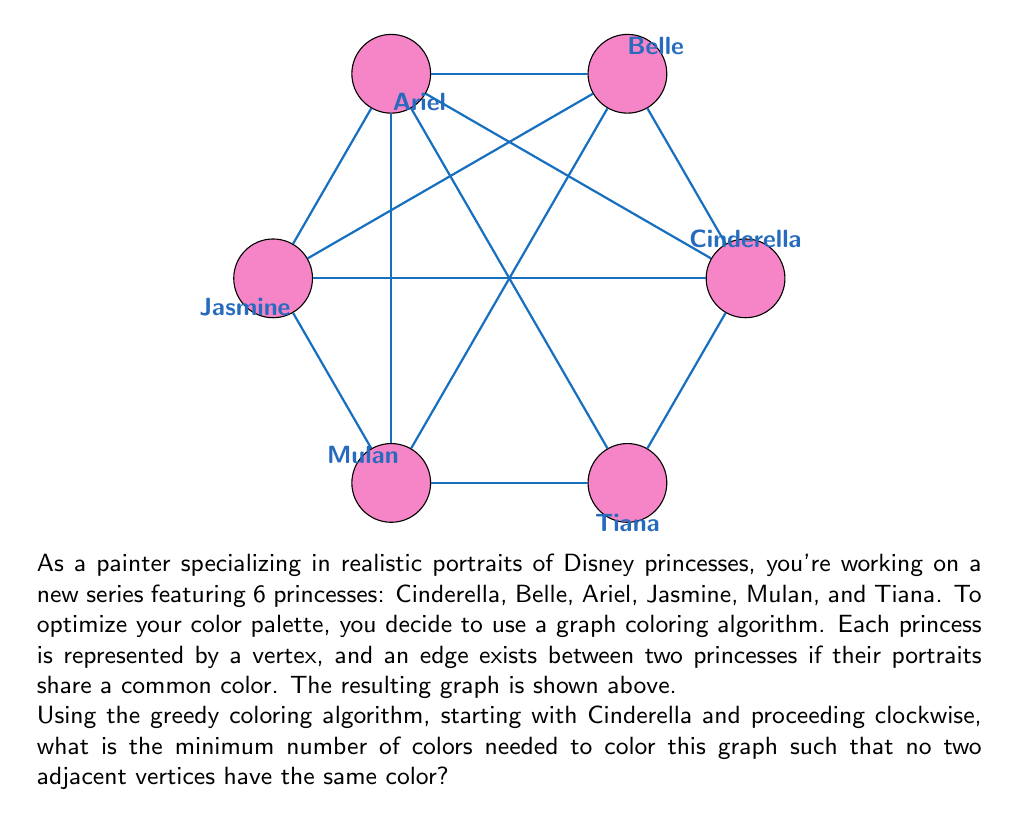Show me your answer to this math problem. Let's apply the greedy coloring algorithm step-by-step:

1) Start with Cinderella. Assign her Color 1.

2) Move to Belle. She's connected to Cinderella, so we can't use Color 1. Assign her Color 2.

3) Ariel is connected to both Cinderella and Belle, so we need a new color. Assign her Color 3.

4) Jasmine is connected to Cinderella, Belle, and Ariel. We need a new color. Assign her Color 4.

5) Mulan is connected to Cinderella, Belle, and Jasmine, but not Ariel. We can use Color 3 for Mulan.

6) Tiana is connected to all other princesses except Jasmine. The only available color is Color 4.

The coloring is now complete. We used colors 1, 2, 3, and 4.

To verify this is optimal, we can observe that Cinderella, Belle, Ariel, and Jasmine form a complete subgraph (K4), which requires 4 colors. Therefore, this graph cannot be colored with fewer than 4 colors.

The chromatic number $\chi(G)$ of this graph is thus 4.
Answer: 4 